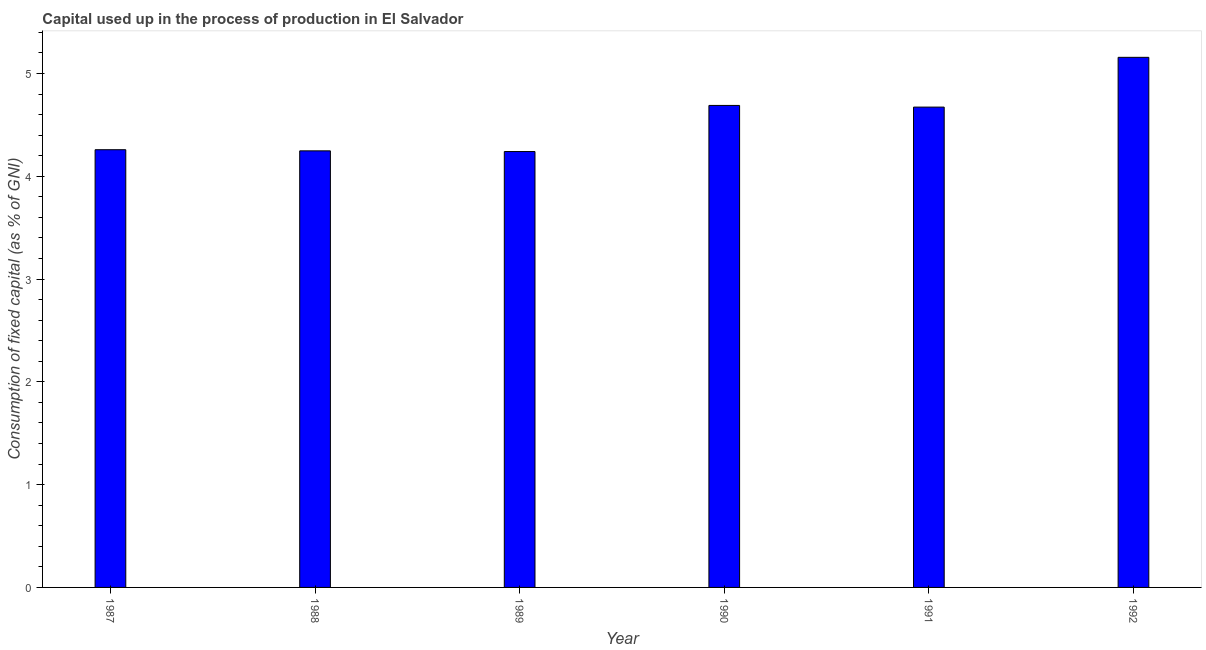What is the title of the graph?
Ensure brevity in your answer.  Capital used up in the process of production in El Salvador. What is the label or title of the Y-axis?
Make the answer very short. Consumption of fixed capital (as % of GNI). What is the consumption of fixed capital in 1990?
Provide a succinct answer. 4.69. Across all years, what is the maximum consumption of fixed capital?
Your answer should be compact. 5.16. Across all years, what is the minimum consumption of fixed capital?
Make the answer very short. 4.24. In which year was the consumption of fixed capital minimum?
Ensure brevity in your answer.  1989. What is the sum of the consumption of fixed capital?
Ensure brevity in your answer.  27.27. What is the difference between the consumption of fixed capital in 1987 and 1991?
Your answer should be compact. -0.41. What is the average consumption of fixed capital per year?
Provide a short and direct response. 4.54. What is the median consumption of fixed capital?
Make the answer very short. 4.47. Do a majority of the years between 1991 and 1989 (inclusive) have consumption of fixed capital greater than 3.4 %?
Your answer should be compact. Yes. What is the ratio of the consumption of fixed capital in 1989 to that in 1992?
Your response must be concise. 0.82. Is the difference between the consumption of fixed capital in 1990 and 1992 greater than the difference between any two years?
Your answer should be compact. No. What is the difference between the highest and the second highest consumption of fixed capital?
Give a very brief answer. 0.47. Is the sum of the consumption of fixed capital in 1990 and 1991 greater than the maximum consumption of fixed capital across all years?
Offer a very short reply. Yes. What is the difference between the highest and the lowest consumption of fixed capital?
Your answer should be very brief. 0.92. In how many years, is the consumption of fixed capital greater than the average consumption of fixed capital taken over all years?
Your answer should be compact. 3. Are the values on the major ticks of Y-axis written in scientific E-notation?
Your answer should be compact. No. What is the Consumption of fixed capital (as % of GNI) of 1987?
Your response must be concise. 4.26. What is the Consumption of fixed capital (as % of GNI) of 1988?
Provide a succinct answer. 4.25. What is the Consumption of fixed capital (as % of GNI) in 1989?
Provide a succinct answer. 4.24. What is the Consumption of fixed capital (as % of GNI) of 1990?
Your response must be concise. 4.69. What is the Consumption of fixed capital (as % of GNI) in 1991?
Keep it short and to the point. 4.67. What is the Consumption of fixed capital (as % of GNI) of 1992?
Provide a short and direct response. 5.16. What is the difference between the Consumption of fixed capital (as % of GNI) in 1987 and 1988?
Provide a succinct answer. 0.01. What is the difference between the Consumption of fixed capital (as % of GNI) in 1987 and 1989?
Your response must be concise. 0.02. What is the difference between the Consumption of fixed capital (as % of GNI) in 1987 and 1990?
Give a very brief answer. -0.43. What is the difference between the Consumption of fixed capital (as % of GNI) in 1987 and 1991?
Make the answer very short. -0.41. What is the difference between the Consumption of fixed capital (as % of GNI) in 1987 and 1992?
Provide a succinct answer. -0.9. What is the difference between the Consumption of fixed capital (as % of GNI) in 1988 and 1989?
Your answer should be compact. 0.01. What is the difference between the Consumption of fixed capital (as % of GNI) in 1988 and 1990?
Provide a succinct answer. -0.44. What is the difference between the Consumption of fixed capital (as % of GNI) in 1988 and 1991?
Your answer should be compact. -0.43. What is the difference between the Consumption of fixed capital (as % of GNI) in 1988 and 1992?
Give a very brief answer. -0.91. What is the difference between the Consumption of fixed capital (as % of GNI) in 1989 and 1990?
Your response must be concise. -0.45. What is the difference between the Consumption of fixed capital (as % of GNI) in 1989 and 1991?
Provide a succinct answer. -0.43. What is the difference between the Consumption of fixed capital (as % of GNI) in 1989 and 1992?
Your answer should be compact. -0.92. What is the difference between the Consumption of fixed capital (as % of GNI) in 1990 and 1991?
Your answer should be compact. 0.02. What is the difference between the Consumption of fixed capital (as % of GNI) in 1990 and 1992?
Offer a terse response. -0.47. What is the difference between the Consumption of fixed capital (as % of GNI) in 1991 and 1992?
Keep it short and to the point. -0.48. What is the ratio of the Consumption of fixed capital (as % of GNI) in 1987 to that in 1989?
Offer a very short reply. 1. What is the ratio of the Consumption of fixed capital (as % of GNI) in 1987 to that in 1990?
Keep it short and to the point. 0.91. What is the ratio of the Consumption of fixed capital (as % of GNI) in 1987 to that in 1991?
Give a very brief answer. 0.91. What is the ratio of the Consumption of fixed capital (as % of GNI) in 1987 to that in 1992?
Keep it short and to the point. 0.83. What is the ratio of the Consumption of fixed capital (as % of GNI) in 1988 to that in 1989?
Provide a short and direct response. 1. What is the ratio of the Consumption of fixed capital (as % of GNI) in 1988 to that in 1990?
Provide a succinct answer. 0.91. What is the ratio of the Consumption of fixed capital (as % of GNI) in 1988 to that in 1991?
Your response must be concise. 0.91. What is the ratio of the Consumption of fixed capital (as % of GNI) in 1988 to that in 1992?
Your response must be concise. 0.82. What is the ratio of the Consumption of fixed capital (as % of GNI) in 1989 to that in 1990?
Provide a short and direct response. 0.9. What is the ratio of the Consumption of fixed capital (as % of GNI) in 1989 to that in 1991?
Provide a succinct answer. 0.91. What is the ratio of the Consumption of fixed capital (as % of GNI) in 1989 to that in 1992?
Your answer should be very brief. 0.82. What is the ratio of the Consumption of fixed capital (as % of GNI) in 1990 to that in 1991?
Make the answer very short. 1. What is the ratio of the Consumption of fixed capital (as % of GNI) in 1990 to that in 1992?
Your answer should be very brief. 0.91. What is the ratio of the Consumption of fixed capital (as % of GNI) in 1991 to that in 1992?
Your response must be concise. 0.91. 